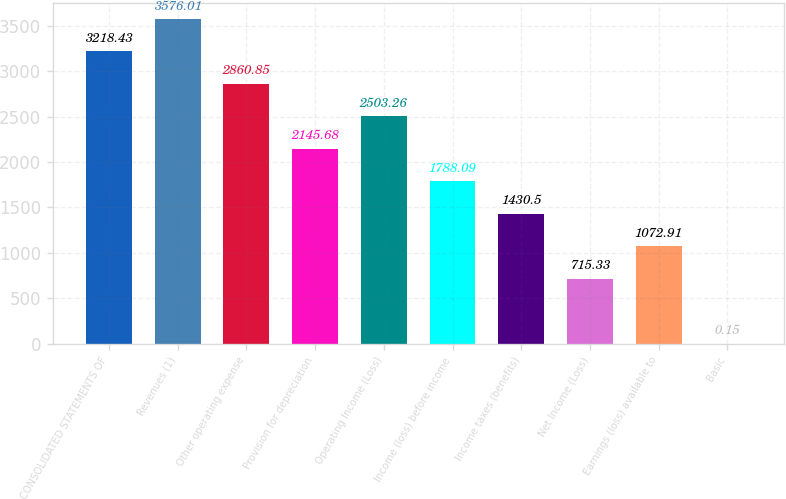Convert chart to OTSL. <chart><loc_0><loc_0><loc_500><loc_500><bar_chart><fcel>CONSOLIDATED STATEMENTS OF<fcel>Revenues (1)<fcel>Other operating expense<fcel>Provision for depreciation<fcel>Operating Income (Loss)<fcel>Income (loss) before income<fcel>Income taxes (benefits)<fcel>Net Income (Loss)<fcel>Earnings (loss) available to<fcel>Basic<nl><fcel>3218.43<fcel>3576.01<fcel>2860.85<fcel>2145.68<fcel>2503.26<fcel>1788.09<fcel>1430.5<fcel>715.33<fcel>1072.91<fcel>0.15<nl></chart> 